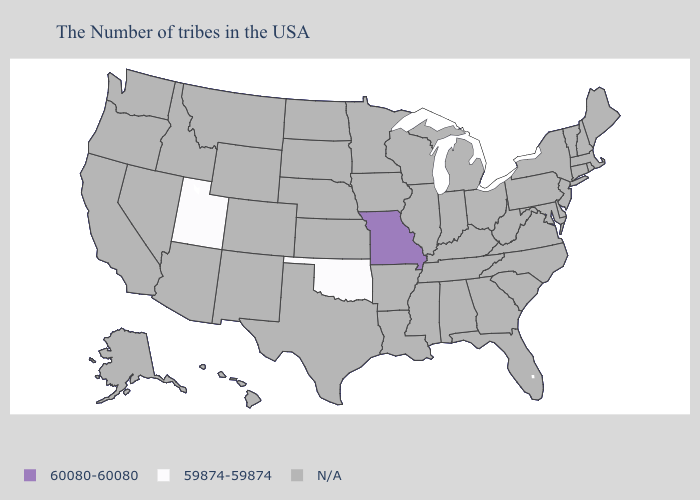What is the highest value in the USA?
Short answer required. 60080-60080. Name the states that have a value in the range 60080-60080?
Answer briefly. Missouri. What is the lowest value in states that border Nebraska?
Concise answer only. 60080-60080. Which states have the lowest value in the USA?
Short answer required. Oklahoma, Utah. Does the first symbol in the legend represent the smallest category?
Answer briefly. No. What is the lowest value in the USA?
Quick response, please. 59874-59874. Is the legend a continuous bar?
Short answer required. No. Which states have the highest value in the USA?
Write a very short answer. Missouri. What is the value of Arizona?
Short answer required. N/A. Which states have the highest value in the USA?
Answer briefly. Missouri. Name the states that have a value in the range 60080-60080?
Write a very short answer. Missouri. What is the lowest value in the USA?
Answer briefly. 59874-59874. Name the states that have a value in the range 59874-59874?
Write a very short answer. Oklahoma, Utah. 